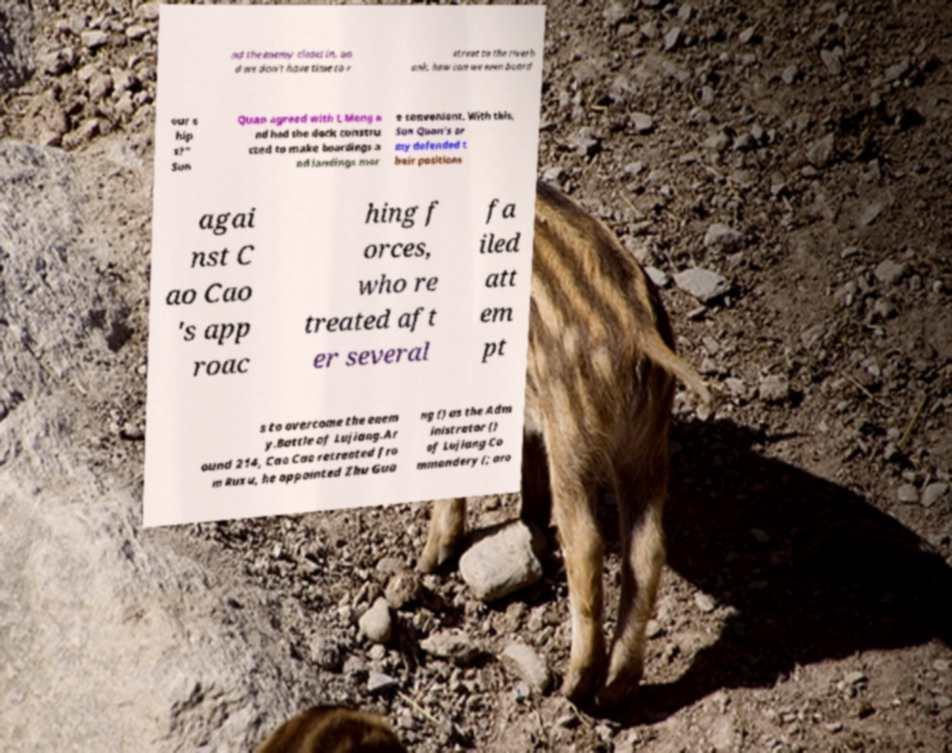Can you accurately transcribe the text from the provided image for me? nd the enemy closes in, an d we don't have time to r etreat to the riverb ank, how can we even board our s hip s?" Sun Quan agreed with L Meng a nd had the dock constru cted to make boardings a nd landings mor e convenient. With this, Sun Quan's ar my defended t heir positions agai nst C ao Cao 's app roac hing f orces, who re treated aft er several fa iled att em pt s to overcome the enem y.Battle of Lujiang.Ar ound 214, Cao Cao retreated fro m Ruxu, he appointed Zhu Gua ng () as the Adm inistrator () of Lujiang Co mmandery (; aro 